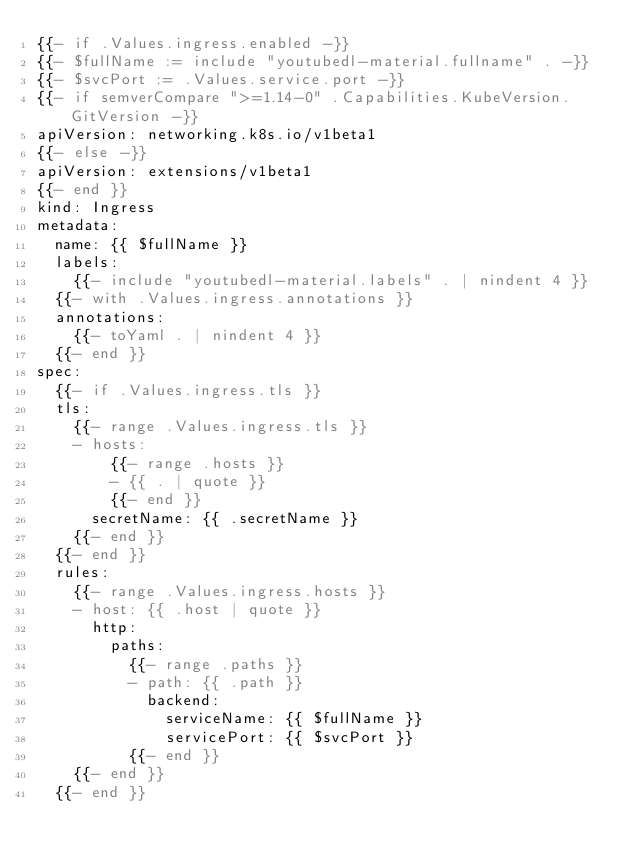Convert code to text. <code><loc_0><loc_0><loc_500><loc_500><_YAML_>{{- if .Values.ingress.enabled -}}
{{- $fullName := include "youtubedl-material.fullname" . -}}
{{- $svcPort := .Values.service.port -}}
{{- if semverCompare ">=1.14-0" .Capabilities.KubeVersion.GitVersion -}}
apiVersion: networking.k8s.io/v1beta1
{{- else -}}
apiVersion: extensions/v1beta1
{{- end }}
kind: Ingress
metadata:
  name: {{ $fullName }}
  labels:
    {{- include "youtubedl-material.labels" . | nindent 4 }}
  {{- with .Values.ingress.annotations }}
  annotations:
    {{- toYaml . | nindent 4 }}
  {{- end }}
spec:
  {{- if .Values.ingress.tls }}
  tls:
    {{- range .Values.ingress.tls }}
    - hosts:
        {{- range .hosts }}
        - {{ . | quote }}
        {{- end }}
      secretName: {{ .secretName }}
    {{- end }}
  {{- end }}
  rules:
    {{- range .Values.ingress.hosts }}
    - host: {{ .host | quote }}
      http:
        paths:
          {{- range .paths }}
          - path: {{ .path }}
            backend:
              serviceName: {{ $fullName }}
              servicePort: {{ $svcPort }}
          {{- end }}
    {{- end }}
  {{- end }}
</code> 